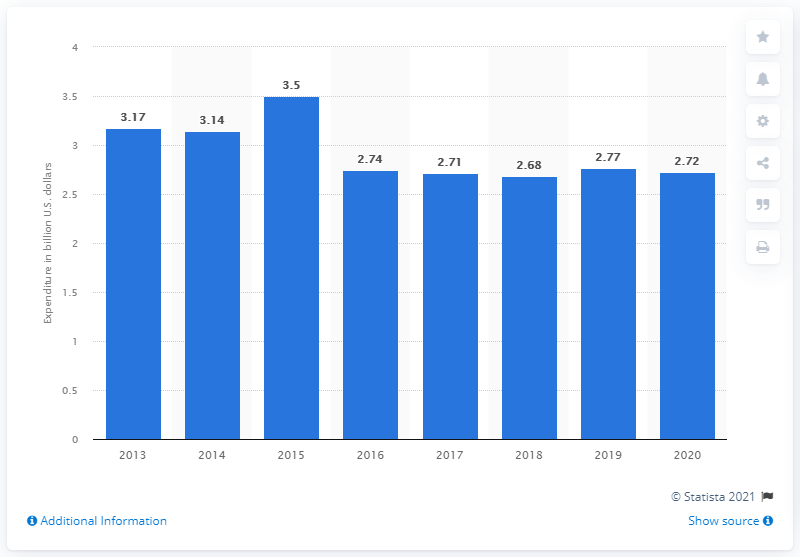Highlight a few significant elements in this photo. The Peruvian government spent 3.5 million in military expenditures in 2015. The Peruvian government spent approximately 2.72 billion dollars on the military in 2020. 